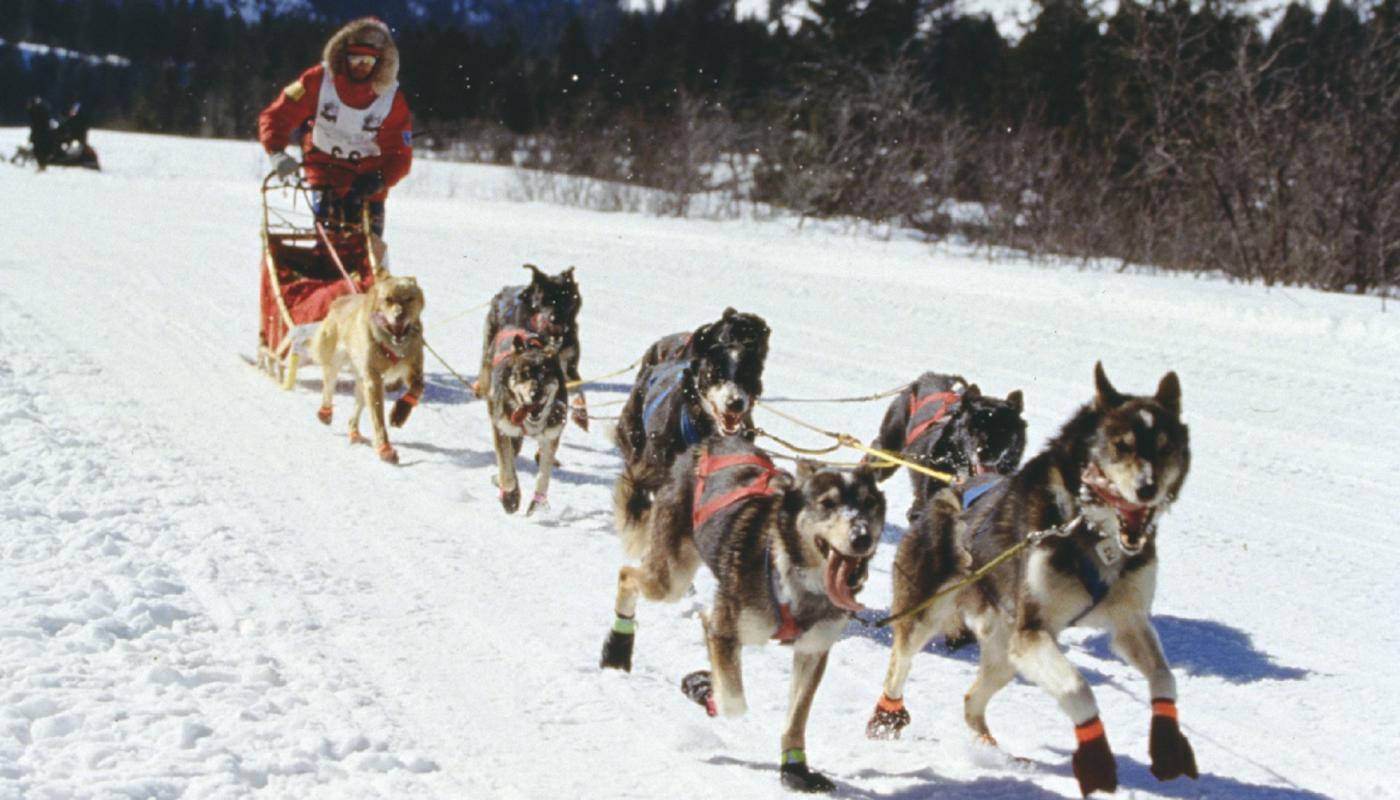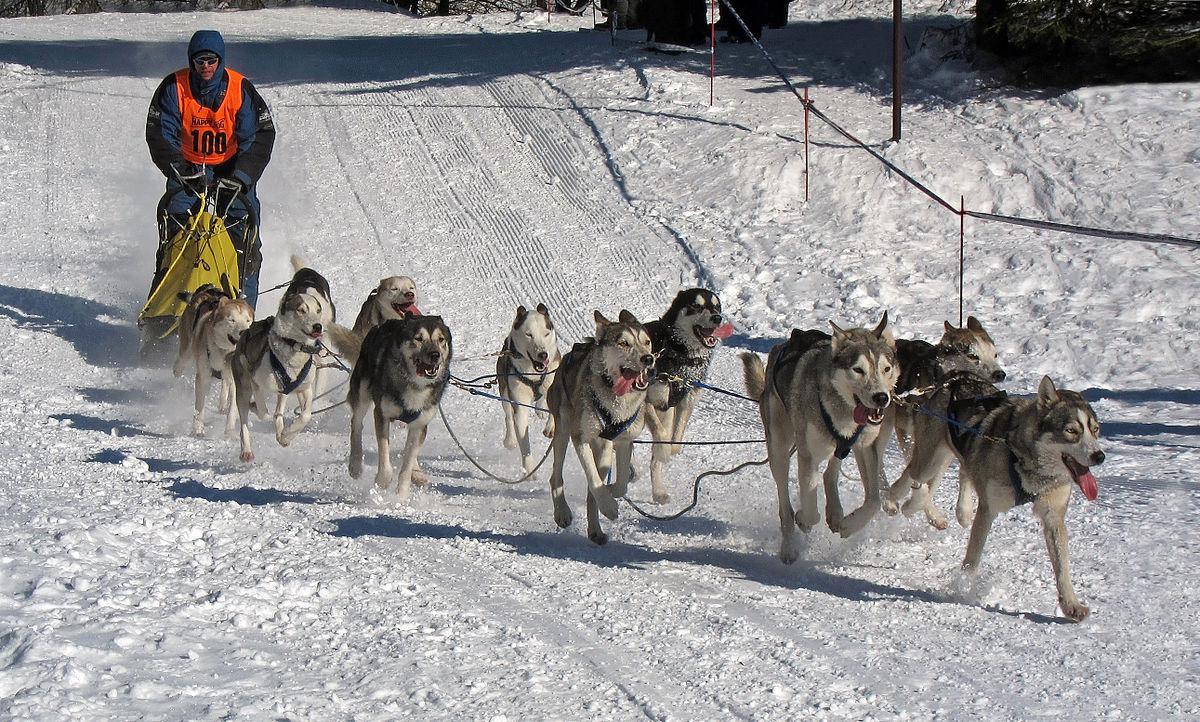The first image is the image on the left, the second image is the image on the right. Assess this claim about the two images: "There are teams of sled dogs pulling dog sleds with mushers on them through the snow.". Correct or not? Answer yes or no. Yes. The first image is the image on the left, the second image is the image on the right. Given the left and right images, does the statement "One image shows a dog sled team without a person." hold true? Answer yes or no. No. 